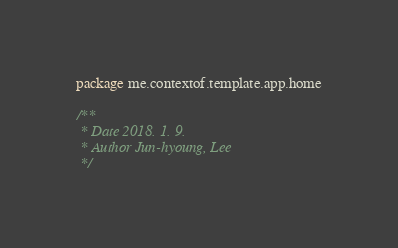Convert code to text. <code><loc_0><loc_0><loc_500><loc_500><_Kotlin_>package me.contextof.template.app.home

/**
 * Date 2018. 1. 9.
 * Author Jun-hyoung, Lee
 */</code> 